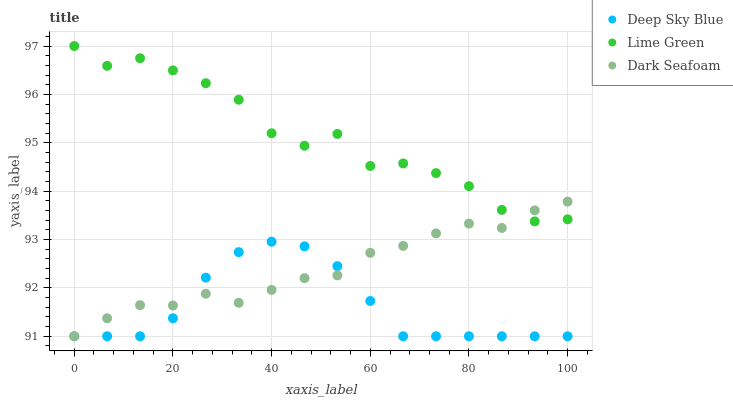Does Deep Sky Blue have the minimum area under the curve?
Answer yes or no. Yes. Does Lime Green have the maximum area under the curve?
Answer yes or no. Yes. Does Lime Green have the minimum area under the curve?
Answer yes or no. No. Does Deep Sky Blue have the maximum area under the curve?
Answer yes or no. No. Is Deep Sky Blue the smoothest?
Answer yes or no. Yes. Is Lime Green the roughest?
Answer yes or no. Yes. Is Lime Green the smoothest?
Answer yes or no. No. Is Deep Sky Blue the roughest?
Answer yes or no. No. Does Dark Seafoam have the lowest value?
Answer yes or no. Yes. Does Lime Green have the lowest value?
Answer yes or no. No. Does Lime Green have the highest value?
Answer yes or no. Yes. Does Deep Sky Blue have the highest value?
Answer yes or no. No. Is Deep Sky Blue less than Lime Green?
Answer yes or no. Yes. Is Lime Green greater than Deep Sky Blue?
Answer yes or no. Yes. Does Dark Seafoam intersect Lime Green?
Answer yes or no. Yes. Is Dark Seafoam less than Lime Green?
Answer yes or no. No. Is Dark Seafoam greater than Lime Green?
Answer yes or no. No. Does Deep Sky Blue intersect Lime Green?
Answer yes or no. No. 